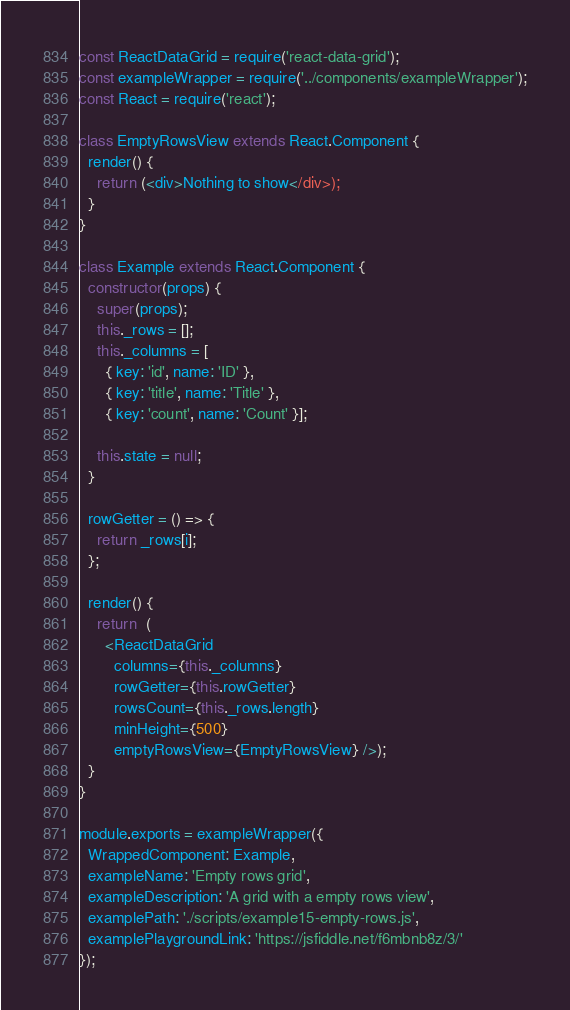Convert code to text. <code><loc_0><loc_0><loc_500><loc_500><_JavaScript_>const ReactDataGrid = require('react-data-grid');
const exampleWrapper = require('../components/exampleWrapper');
const React = require('react');

class EmptyRowsView extends React.Component {
  render() {
    return (<div>Nothing to show</div>);
  }
}

class Example extends React.Component {
  constructor(props) {
    super(props);
    this._rows = [];
    this._columns = [
      { key: 'id', name: 'ID' },
      { key: 'title', name: 'Title' },
      { key: 'count', name: 'Count' }];

    this.state = null;
  }

  rowGetter = () => {
    return _rows[i];
  };

  render() {
    return  (
      <ReactDataGrid
        columns={this._columns}
        rowGetter={this.rowGetter}
        rowsCount={this._rows.length}
        minHeight={500}
        emptyRowsView={EmptyRowsView} />);
  }
}

module.exports = exampleWrapper({
  WrappedComponent: Example,
  exampleName: 'Empty rows grid',
  exampleDescription: 'A grid with a empty rows view',
  examplePath: './scripts/example15-empty-rows.js',
  examplePlaygroundLink: 'https://jsfiddle.net/f6mbnb8z/3/'
});</code> 